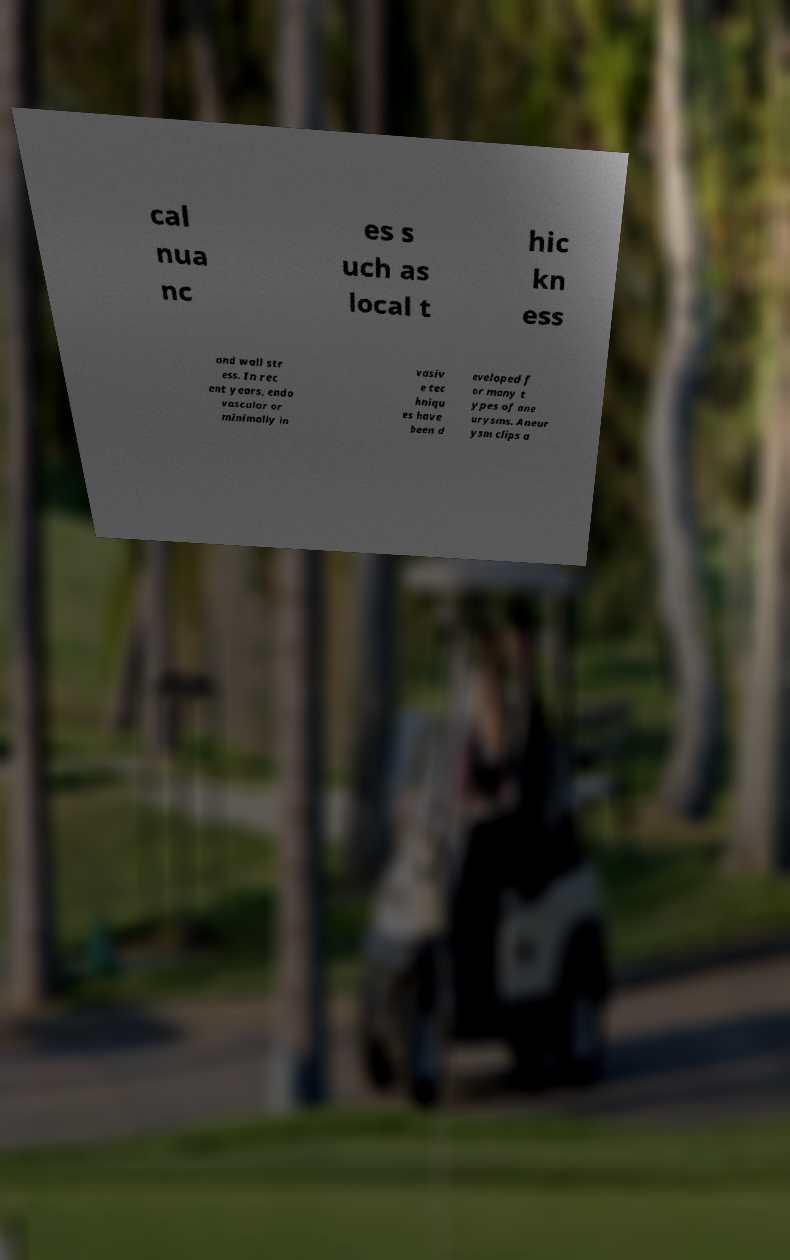There's text embedded in this image that I need extracted. Can you transcribe it verbatim? cal nua nc es s uch as local t hic kn ess and wall str ess. In rec ent years, endo vascular or minimally in vasiv e tec hniqu es have been d eveloped f or many t ypes of ane urysms. Aneur ysm clips a 